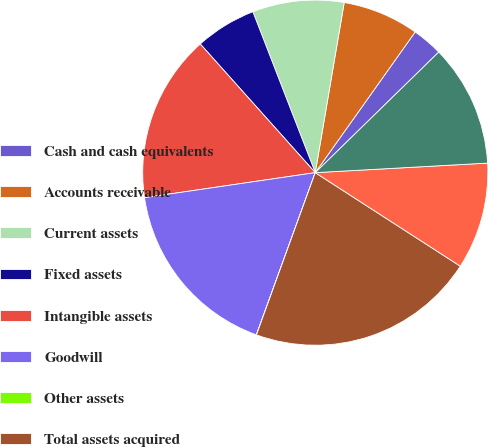Convert chart. <chart><loc_0><loc_0><loc_500><loc_500><pie_chart><fcel>Cash and cash equivalents<fcel>Accounts receivable<fcel>Current assets<fcel>Fixed assets<fcel>Intangible assets<fcel>Goodwill<fcel>Other assets<fcel>Total assets acquired<fcel>Current liabilities<fcel>Deferred revenues<nl><fcel>2.86%<fcel>7.15%<fcel>8.57%<fcel>5.72%<fcel>15.71%<fcel>17.14%<fcel>0.01%<fcel>21.42%<fcel>10.0%<fcel>11.43%<nl></chart> 